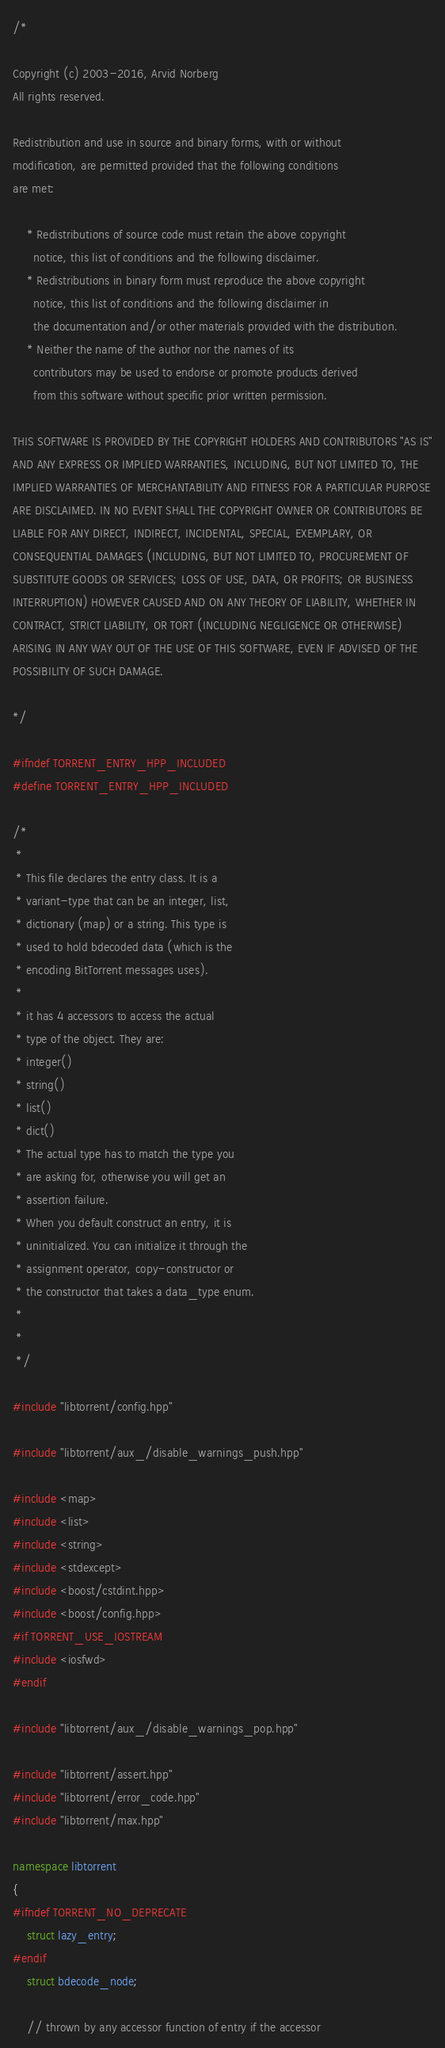<code> <loc_0><loc_0><loc_500><loc_500><_C++_>/*

Copyright (c) 2003-2016, Arvid Norberg
All rights reserved.

Redistribution and use in source and binary forms, with or without
modification, are permitted provided that the following conditions
are met:

    * Redistributions of source code must retain the above copyright
      notice, this list of conditions and the following disclaimer.
    * Redistributions in binary form must reproduce the above copyright
      notice, this list of conditions and the following disclaimer in
      the documentation and/or other materials provided with the distribution.
    * Neither the name of the author nor the names of its
      contributors may be used to endorse or promote products derived
      from this software without specific prior written permission.

THIS SOFTWARE IS PROVIDED BY THE COPYRIGHT HOLDERS AND CONTRIBUTORS "AS IS"
AND ANY EXPRESS OR IMPLIED WARRANTIES, INCLUDING, BUT NOT LIMITED TO, THE
IMPLIED WARRANTIES OF MERCHANTABILITY AND FITNESS FOR A PARTICULAR PURPOSE
ARE DISCLAIMED. IN NO EVENT SHALL THE COPYRIGHT OWNER OR CONTRIBUTORS BE
LIABLE FOR ANY DIRECT, INDIRECT, INCIDENTAL, SPECIAL, EXEMPLARY, OR
CONSEQUENTIAL DAMAGES (INCLUDING, BUT NOT LIMITED TO, PROCUREMENT OF
SUBSTITUTE GOODS OR SERVICES; LOSS OF USE, DATA, OR PROFITS; OR BUSINESS
INTERRUPTION) HOWEVER CAUSED AND ON ANY THEORY OF LIABILITY, WHETHER IN
CONTRACT, STRICT LIABILITY, OR TORT (INCLUDING NEGLIGENCE OR OTHERWISE)
ARISING IN ANY WAY OUT OF THE USE OF THIS SOFTWARE, EVEN IF ADVISED OF THE
POSSIBILITY OF SUCH DAMAGE.

*/

#ifndef TORRENT_ENTRY_HPP_INCLUDED
#define TORRENT_ENTRY_HPP_INCLUDED

/*
 *
 * This file declares the entry class. It is a
 * variant-type that can be an integer, list,
 * dictionary (map) or a string. This type is
 * used to hold bdecoded data (which is the
 * encoding BitTorrent messages uses).
 *
 * it has 4 accessors to access the actual
 * type of the object. They are:
 * integer()
 * string()
 * list()
 * dict()
 * The actual type has to match the type you
 * are asking for, otherwise you will get an
 * assertion failure.
 * When you default construct an entry, it is
 * uninitialized. You can initialize it through the
 * assignment operator, copy-constructor or
 * the constructor that takes a data_type enum.
 *
 *
 */

#include "libtorrent/config.hpp"

#include "libtorrent/aux_/disable_warnings_push.hpp"

#include <map>
#include <list>
#include <string>
#include <stdexcept>
#include <boost/cstdint.hpp>
#include <boost/config.hpp>
#if TORRENT_USE_IOSTREAM
#include <iosfwd>
#endif

#include "libtorrent/aux_/disable_warnings_pop.hpp"

#include "libtorrent/assert.hpp"
#include "libtorrent/error_code.hpp"
#include "libtorrent/max.hpp"

namespace libtorrent
{
#ifndef TORRENT_NO_DEPRECATE
	struct lazy_entry;
#endif
	struct bdecode_node;

	// thrown by any accessor function of entry if the accessor</code> 